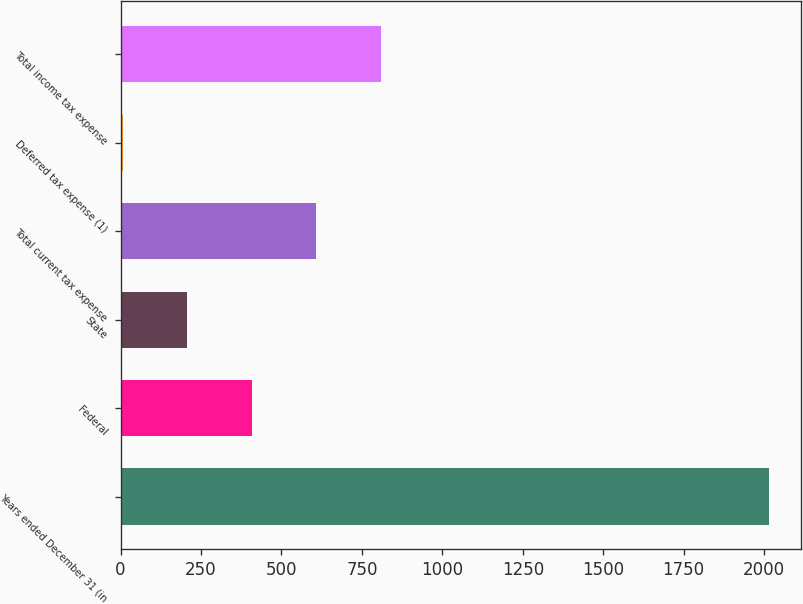<chart> <loc_0><loc_0><loc_500><loc_500><bar_chart><fcel>Years ended December 31 (in<fcel>Federal<fcel>State<fcel>Total current tax expense<fcel>Deferred tax expense (1)<fcel>Total income tax expense<nl><fcel>2014<fcel>408.16<fcel>207.43<fcel>608.89<fcel>6.7<fcel>809.62<nl></chart> 